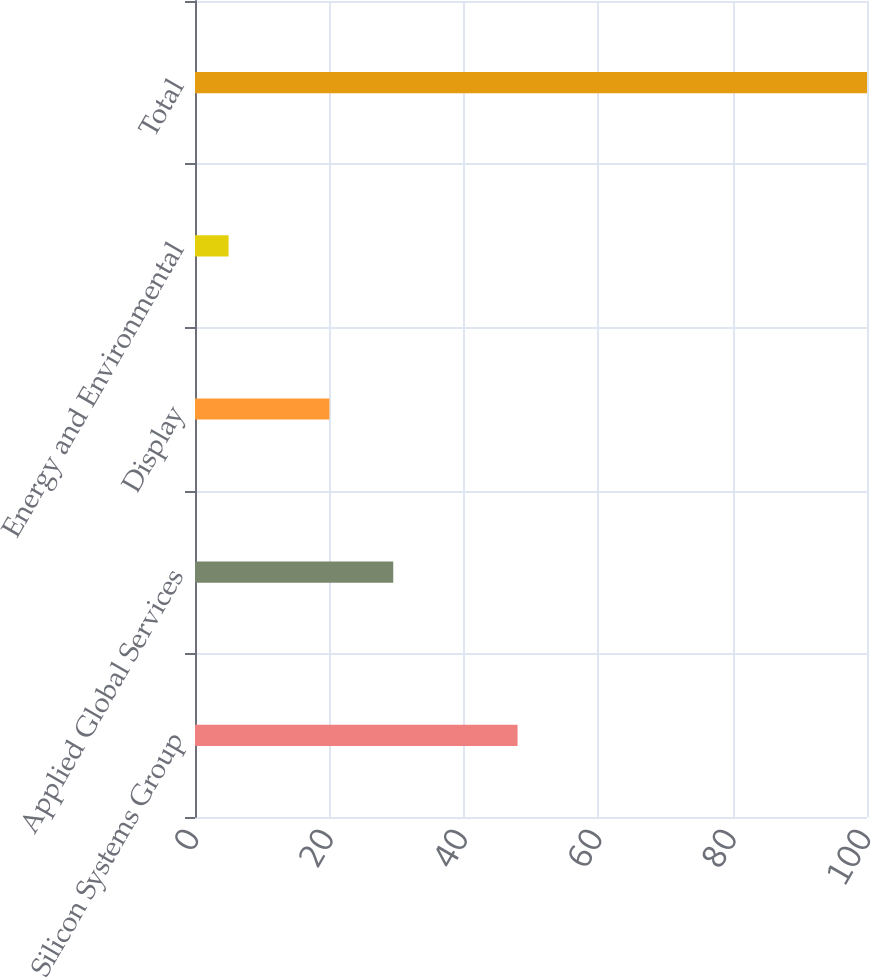Convert chart. <chart><loc_0><loc_0><loc_500><loc_500><bar_chart><fcel>Silicon Systems Group<fcel>Applied Global Services<fcel>Display<fcel>Energy and Environmental<fcel>Total<nl><fcel>48<fcel>29.5<fcel>20<fcel>5<fcel>100<nl></chart> 